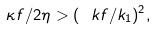<formula> <loc_0><loc_0><loc_500><loc_500>\kappa f / 2 \eta > ( \ k f / k _ { 1 } ) ^ { 2 } ,</formula> 